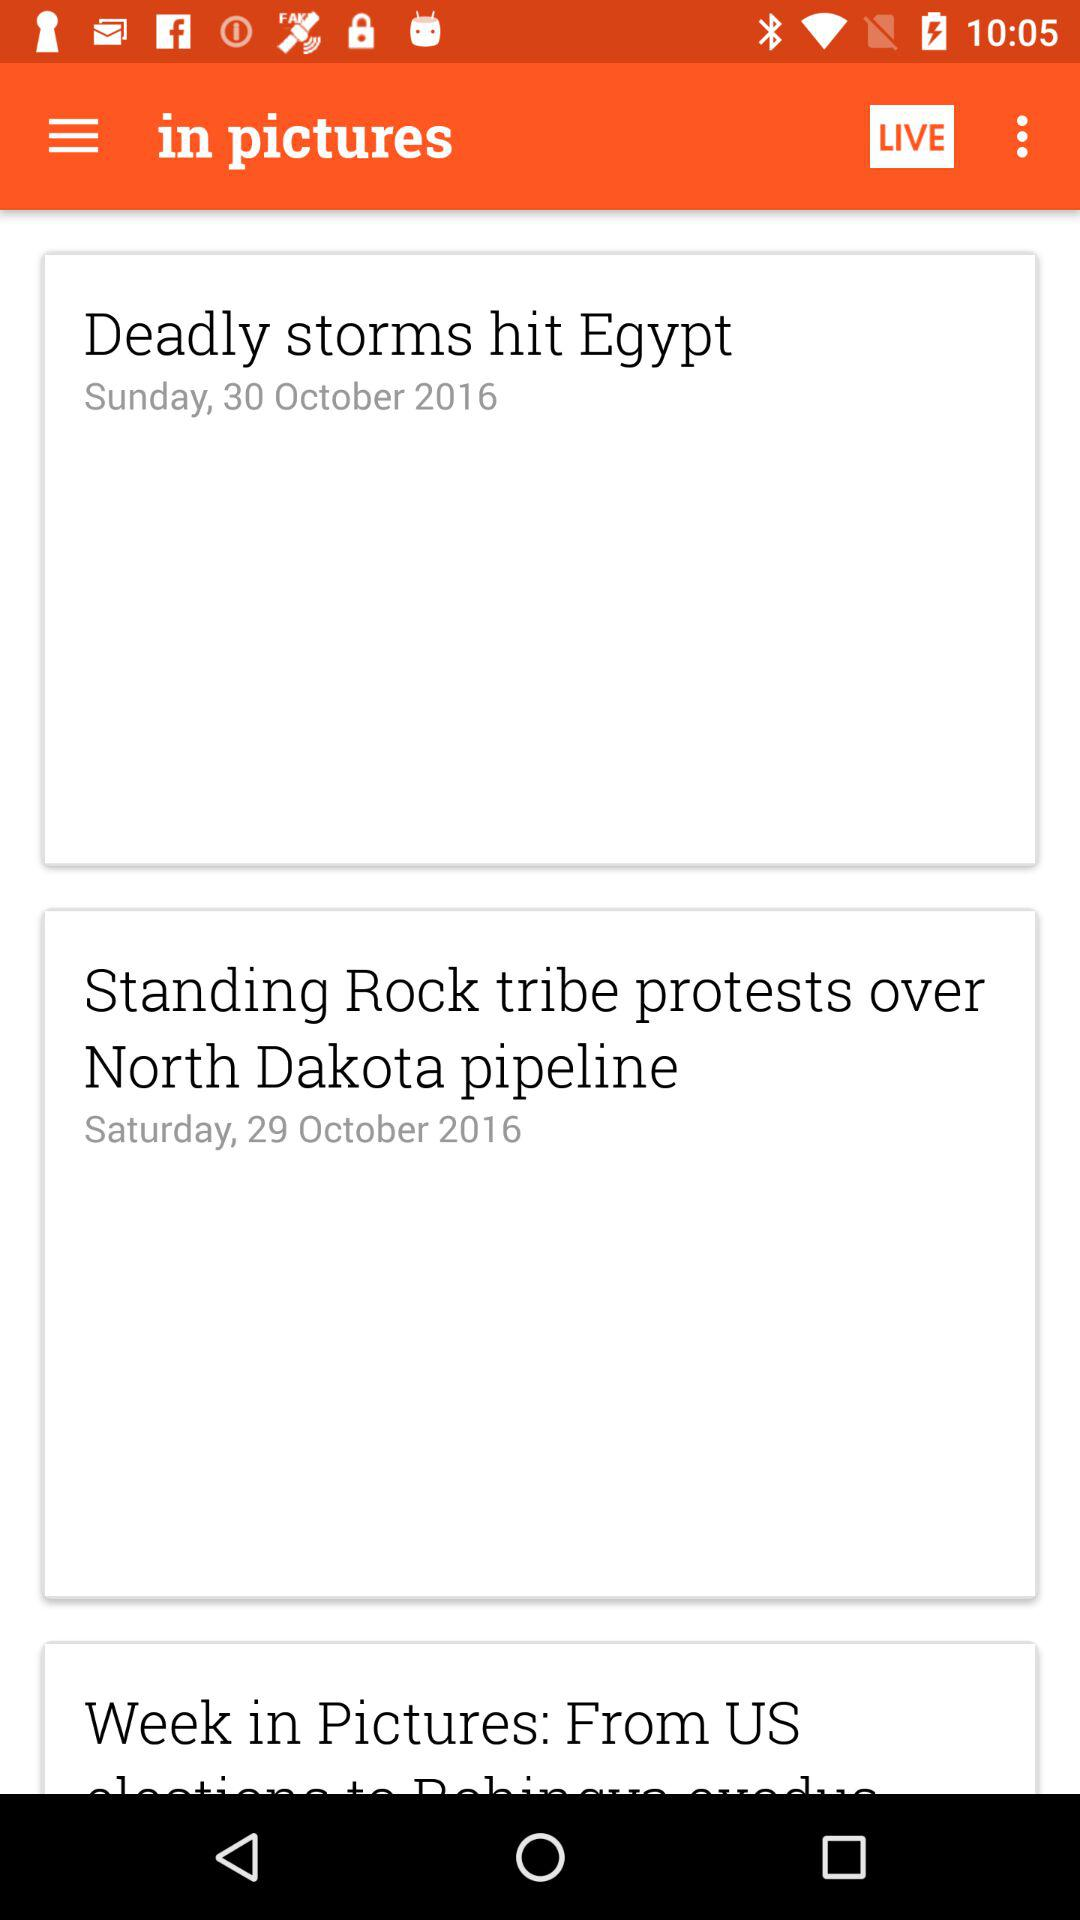What day is it on October 29, 2016? The day is Saturday. 